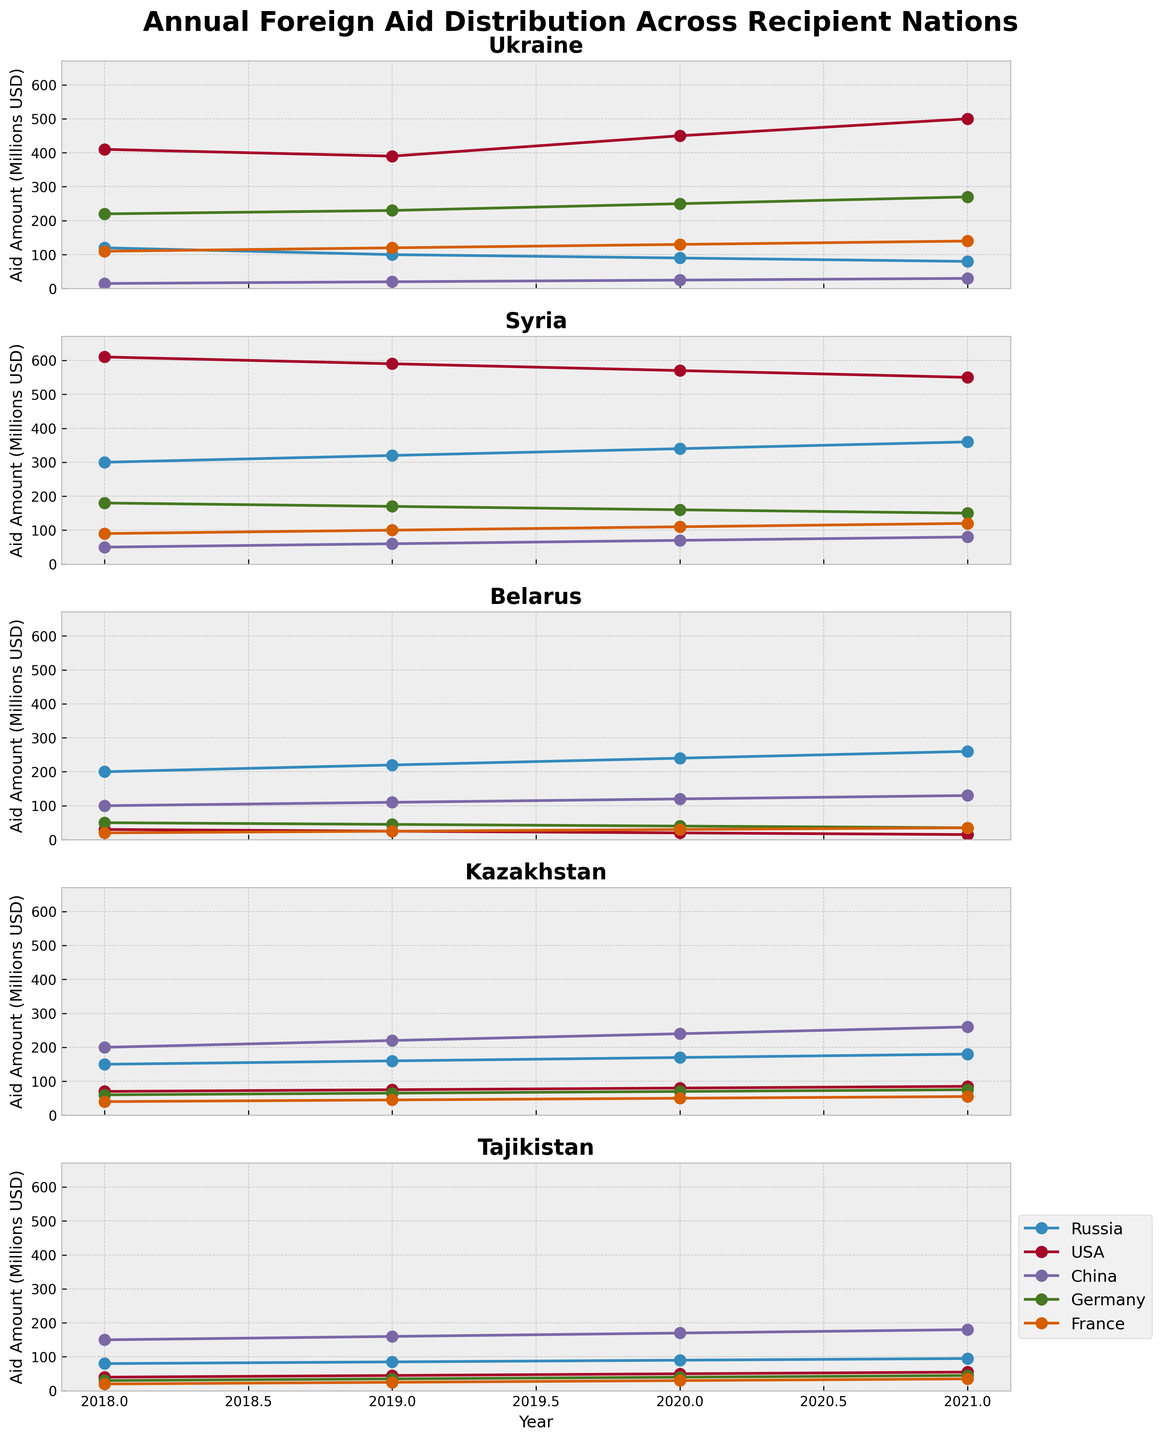Which country received the highest amount of aid from Russia in 2018? To find the answer, look at the data points for Russia in 2018 across all countries. The highest amount from Russia in 2018 was for Syria.
Answer: Syria Which country saw the biggest increase in US aid from 2018 to 2021? Calculate the difference between 2021 and 2018 for US aid for each country. The country with the largest difference is Ukraine (500 - 410 = 90).
Answer: Ukraine For which country did France steadily increase its aid every year from 2018 to 2021? Check the data points for France from 2018 to 2021 across all countries. The only country where aid increased every year is Belarus (20, 25, 30, 35).
Answer: Belarus Which year did China start providing aid to Ukraine, and how much was it? See the data points for China and Ukraine. China's aid starts appearing in 2018, with 15 million USD.
Answer: 2018, 15 million USD Between which years did Germany's aid to Kazakhstan remain constant? Check the data points for Germany's aid to Kazakhstan. Aid amounts remain constant between 2019 and 2020 (65).
Answer: 2019 and 2020 Which country received the most significant cumulative aid from France over the years 2018-2021? Sum the aid from France for all years for each country. Syria, with (90+100+110+120) = 420 million USD, received the highest cumulative aid.
Answer: Syria Compare the trend of aid received by Tajikistan from the USA and China. Which donor showed a more consistent increase? Look at the trend lines for the USA and China for Tajikistan. Both show an increase, but China's increase (150 to 180) is more consistent.
Answer: China Which country received decreasing aid from Russia over the years 2018-2021? Observe the aid amounts from Russia across all countries. Only Ukraine shows consistently decreasing aid (120, 100, 90, 80).
Answer: Ukraine 